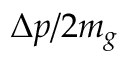<formula> <loc_0><loc_0><loc_500><loc_500>\Delta p / 2 m _ { g }</formula> 